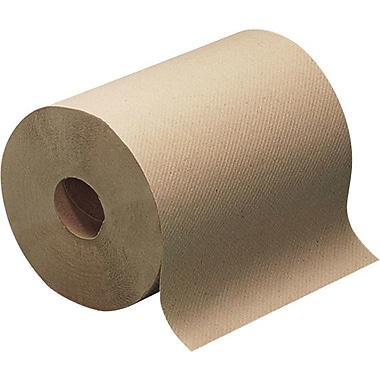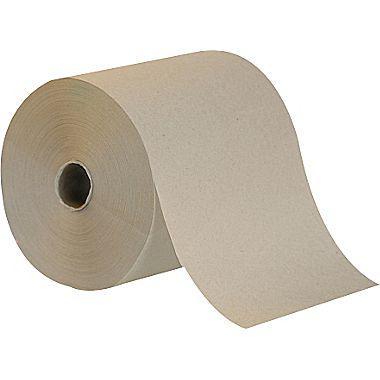The first image is the image on the left, the second image is the image on the right. For the images displayed, is the sentence "There is a folded paper towel on one of the images." factually correct? Answer yes or no. No. 